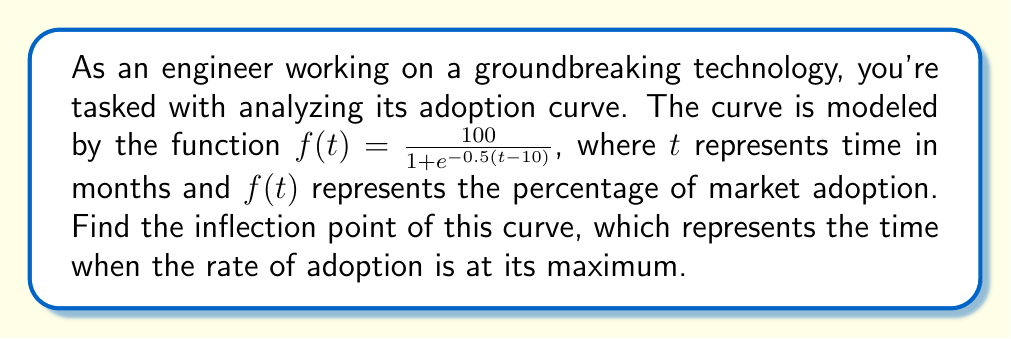Give your solution to this math problem. To find the inflection point, we need to follow these steps:

1) The inflection point occurs where the second derivative of $f(t)$ equals zero.

2) First, let's find $f'(t)$:
   $$f'(t) = \frac{100 \cdot 0.5e^{-0.5(t-10)}}{(1 + e^{-0.5(t-10)})^2} = \frac{50e^{-0.5(t-10)}}{(1 + e^{-0.5(t-10)})^2}$$

3) Now, let's find $f''(t)$:
   $$f''(t) = \frac{50e^{-0.5(t-10)}}{(1 + e^{-0.5(t-10)})^2} \cdot \left(\frac{-0.5(1 + e^{-0.5(t-10)}) - 2(-0.5e^{-0.5(t-10)})}{1 + e^{-0.5(t-10)}}\right)$$

4) Simplify $f''(t)$:
   $$f''(t) = \frac{50e^{-0.5(t-10)}}{(1 + e^{-0.5(t-10)})^3} \cdot (e^{-0.5(t-10)} - 1)$$

5) Set $f''(t) = 0$ and solve for $t$:
   $$\frac{50e^{-0.5(t-10)}}{(1 + e^{-0.5(t-10)})^3} \cdot (e^{-0.5(t-10)} - 1) = 0$$

6) The first factor is always positive, so the second factor must be zero:
   $$e^{-0.5(t-10)} - 1 = 0$$
   $$e^{-0.5(t-10)} = 1$$
   $$-0.5(t-10) = 0$$
   $$t = 10$$

7) Therefore, the inflection point occurs at $t = 10$ months.
Answer: 10 months 